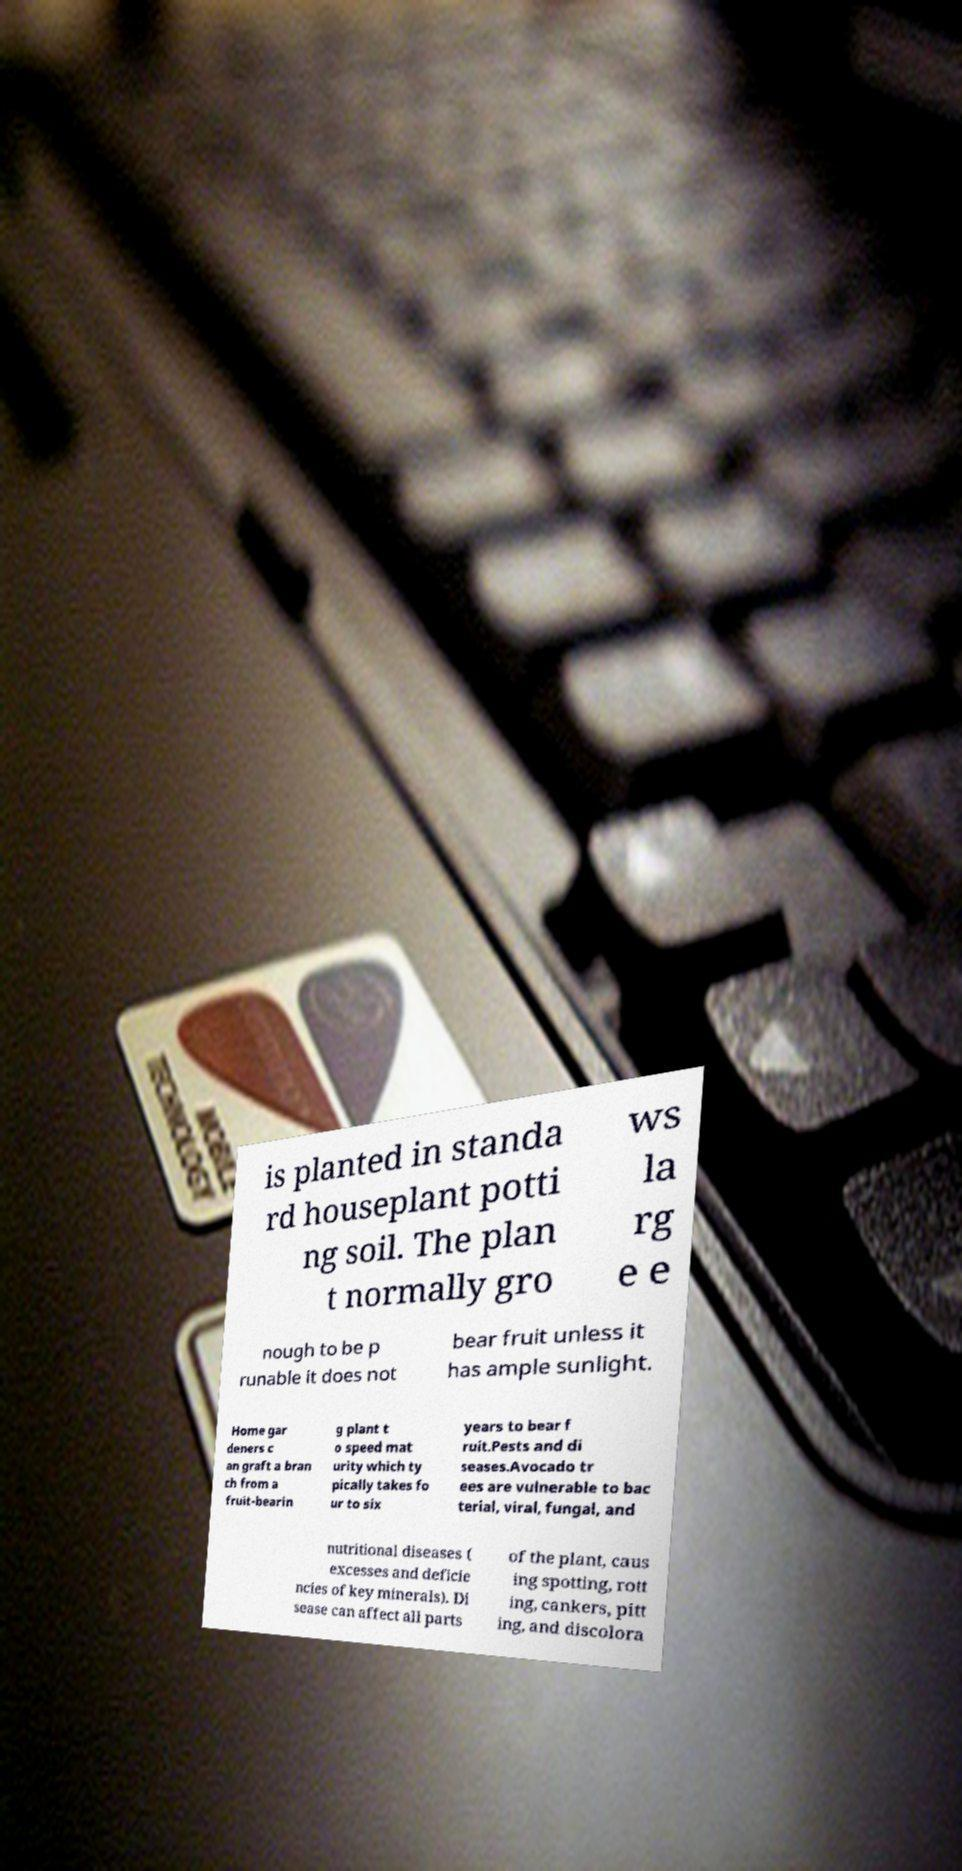There's text embedded in this image that I need extracted. Can you transcribe it verbatim? is planted in standa rd houseplant potti ng soil. The plan t normally gro ws la rg e e nough to be p runable it does not bear fruit unless it has ample sunlight. Home gar deners c an graft a bran ch from a fruit-bearin g plant t o speed mat urity which ty pically takes fo ur to six years to bear f ruit.Pests and di seases.Avocado tr ees are vulnerable to bac terial, viral, fungal, and nutritional diseases ( excesses and deficie ncies of key minerals). Di sease can affect all parts of the plant, caus ing spotting, rott ing, cankers, pitt ing, and discolora 